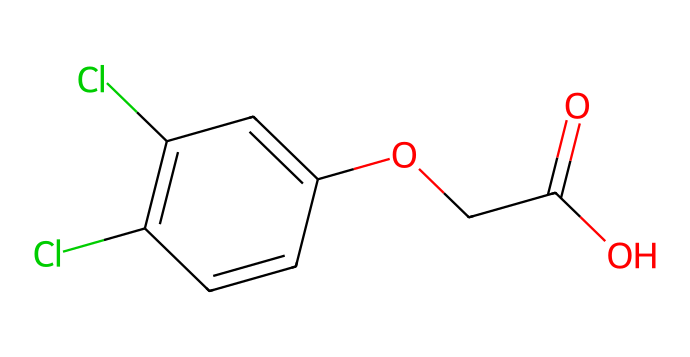What is the molecular formula for 2,4-D? To find the molecular formula, we need to count the number of each type of atom present in the SMILES representation. The SMILES indicates the presence of carbon (C), hydrogen (H), oxygen (O), and chlorine (Cl) atoms. Upon analyzing the structure, we can determine the count: there are 8 carbon atoms, 7 hydrogen atoms, 2 oxygen atoms, and 2 chlorine atoms. Therefore, the molecular formula is C8H6Cl2O3.
Answer: C8H6Cl2O3 How many chlorine atoms are present in 2,4-D? Looking at the SMILES representation, we specifically see two instances of the character "Cl." This indicates that there are two chlorine atoms attached to the carbon structure.
Answer: 2 What type of functional groups can be identified in 2,4-D? The SMILES representation highlights the presence of a carboxylic acid group (-COOH) indicated by "C(=O)O" and an ether group signified by "OCC." Recognizing these fragments leads us to classify the functional groups accordingly.
Answer: carboxylic acid and ether What is the total number of rings in the structure of 2,4-D? By analyzing the SMILES, we locate "C1" which indicates the start of a cyclic structure. Further exploration leads to another "C1" denoting the closing of the same ring. Since there is only one cycle present in the structure, we conclude that there is a single ring.
Answer: 1 What is the significance of the aromatic ring in 2,4-D? In the SMILES string, the presence of alternating double bonds within the "C=C" sections indicates an aromatic ring. Aromatic rings contribute to the stability and lipophilicity of the herbicide, increasing its effectiveness in weed management.
Answer: stability and lipophilicity Which part of 2,4-D contributes to its herbicidal activity? The molecular structure includes both an aromatic ring and a carboxylic acid group. The carboxylic acid functional group plays a crucial role in the herbicide's activity as it interferes with the growth processes of the plants. Thus, this specific group is essential for its herbicidal action.
Answer: carboxylic acid group 